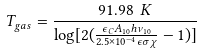Convert formula to latex. <formula><loc_0><loc_0><loc_500><loc_500>T _ { g a s } = \frac { 9 1 . 9 8 \ K } { \log [ 2 ( \frac { \epsilon _ { C } A _ { 1 0 } h \nu _ { 1 0 } } { 2 . 5 \times 1 0 ^ { - 4 } \epsilon \sigma \chi } - 1 ) ] }</formula> 